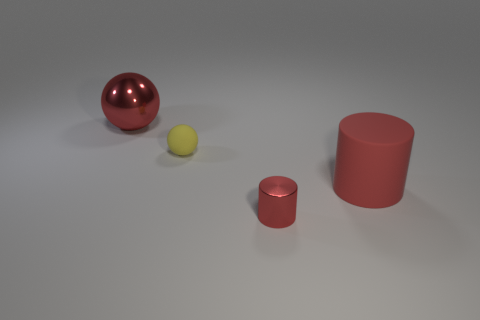Does the metallic sphere have the same size as the metallic thing in front of the small yellow object?
Provide a succinct answer. No. What number of rubber objects are spheres or small green cubes?
Your answer should be very brief. 1. How many big red objects have the same shape as the yellow object?
Provide a succinct answer. 1. There is another big object that is the same color as the large rubber object; what material is it?
Offer a very short reply. Metal. There is a red thing that is to the left of the yellow object; is its size the same as the matte thing to the right of the tiny matte thing?
Give a very brief answer. Yes. There is a red thing that is in front of the large red cylinder; what is its shape?
Keep it short and to the point. Cylinder. What material is the other thing that is the same shape as the big rubber object?
Provide a succinct answer. Metal. There is a red shiny thing that is in front of the yellow rubber object; is it the same size as the red shiny sphere?
Ensure brevity in your answer.  No. How many small matte balls are behind the shiny ball?
Make the answer very short. 0. Is the number of tiny red cylinders in front of the matte cylinder less than the number of red objects that are on the left side of the large shiny ball?
Offer a terse response. No. 